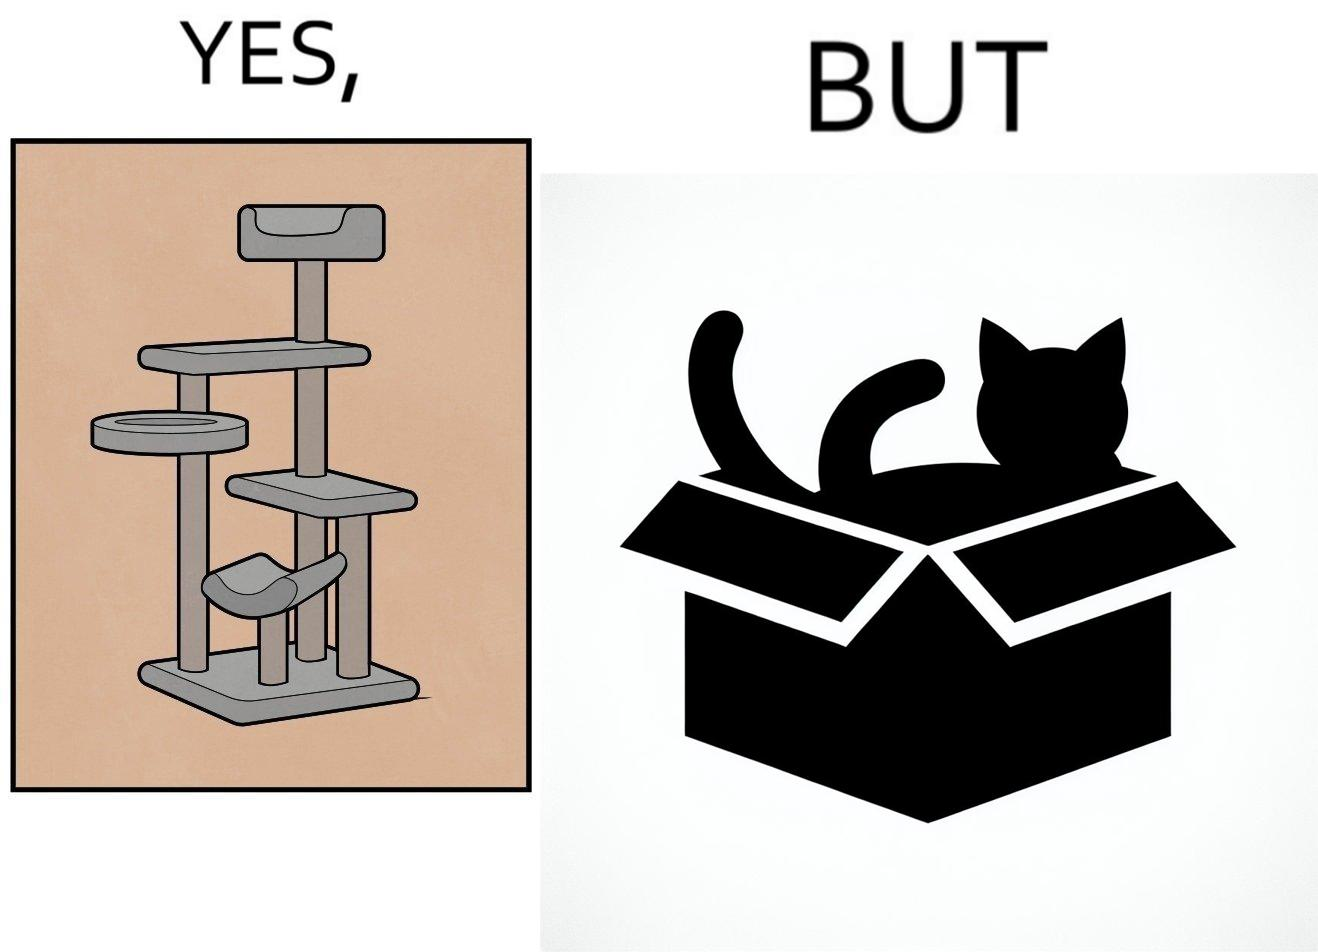Describe what you see in the left and right parts of this image. In the left part of the image: It is a cat tree In the right part of the image: It is a cat in a cardboard box 